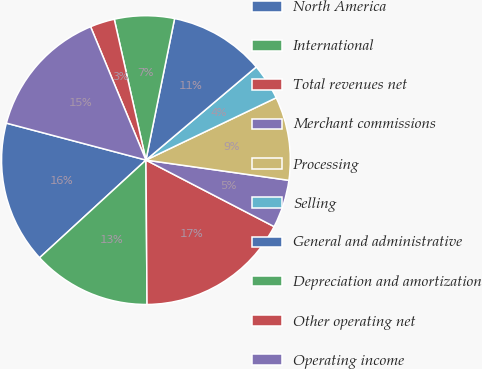Convert chart. <chart><loc_0><loc_0><loc_500><loc_500><pie_chart><fcel>North America<fcel>International<fcel>Total revenues net<fcel>Merchant commissions<fcel>Processing<fcel>Selling<fcel>General and administrative<fcel>Depreciation and amortization<fcel>Other operating net<fcel>Operating income<nl><fcel>15.94%<fcel>13.3%<fcel>17.26%<fcel>5.38%<fcel>9.34%<fcel>4.06%<fcel>10.66%<fcel>6.7%<fcel>2.74%<fcel>14.62%<nl></chart> 